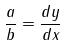Convert formula to latex. <formula><loc_0><loc_0><loc_500><loc_500>\frac { a } { b } = \frac { d y } { d x }</formula> 